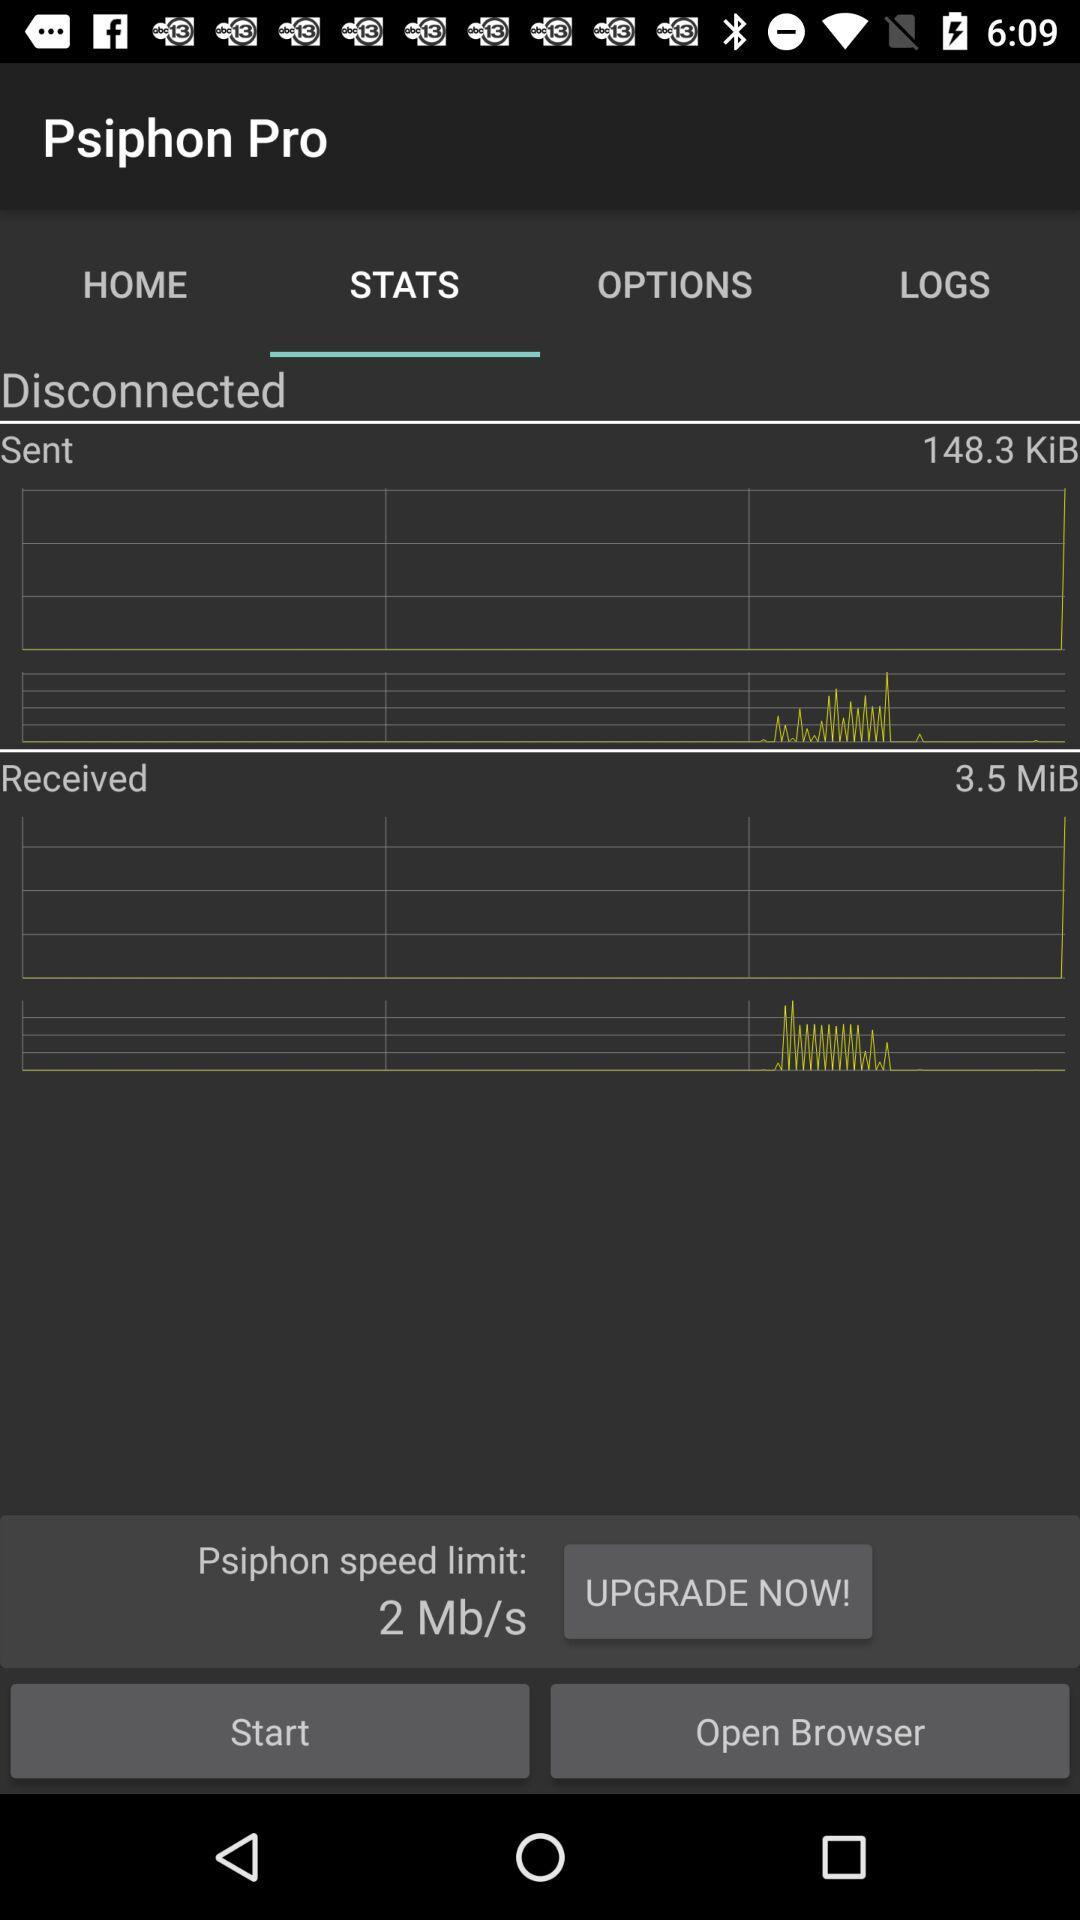Which tab is selected? The selected tab is "STATS". 